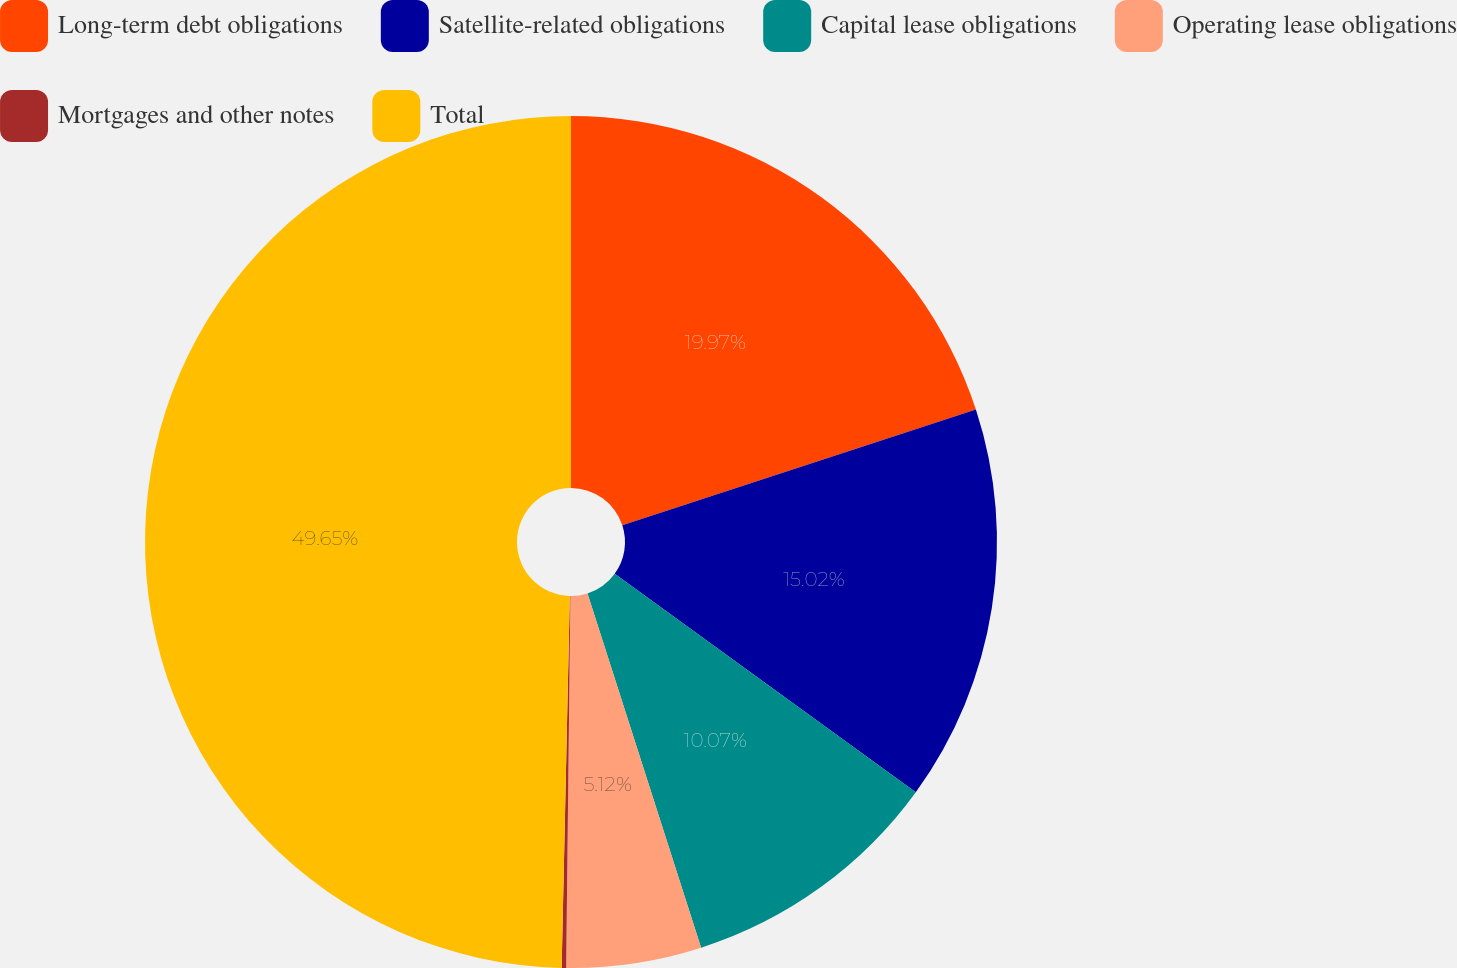Convert chart. <chart><loc_0><loc_0><loc_500><loc_500><pie_chart><fcel>Long-term debt obligations<fcel>Satellite-related obligations<fcel>Capital lease obligations<fcel>Operating lease obligations<fcel>Mortgages and other notes<fcel>Total<nl><fcel>19.97%<fcel>15.02%<fcel>10.07%<fcel>5.12%<fcel>0.17%<fcel>49.65%<nl></chart> 